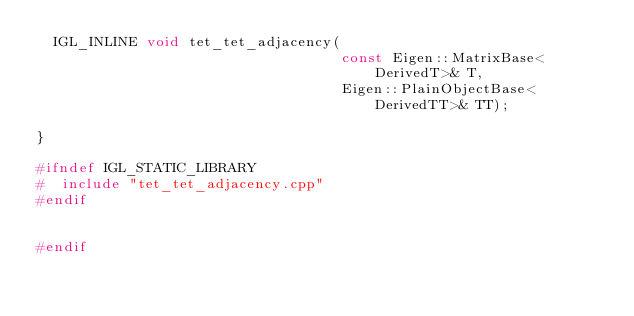Convert code to text. <code><loc_0><loc_0><loc_500><loc_500><_C_>  IGL_INLINE void tet_tet_adjacency(
                                    const Eigen::MatrixBase<DerivedT>& T,
                                    Eigen::PlainObjectBase<DerivedTT>& TT);
    
}

#ifndef IGL_STATIC_LIBRARY
#  include "tet_tet_adjacency.cpp"
#endif


#endif
</code> 